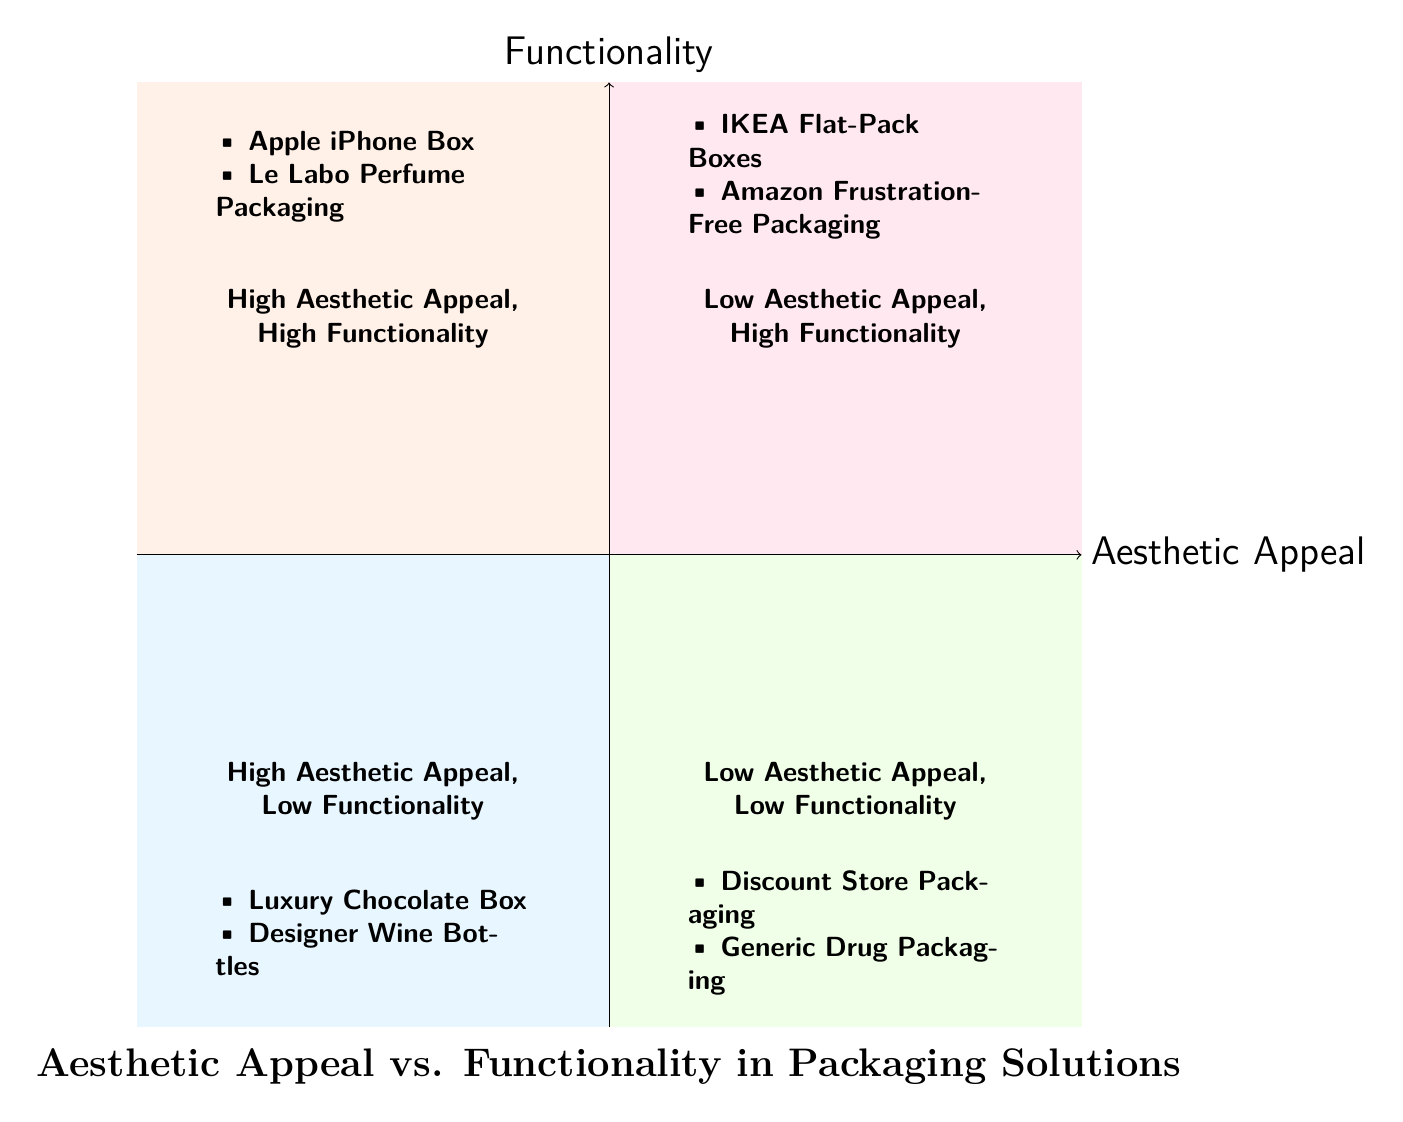What are the two examples in the high aesthetic appeal, high functionality quadrant? The quadrant contains two specific examples: the Apple iPhone Box and the Le Labo Perfume Packaging.
Answer: Apple iPhone Box, Le Labo Perfume Packaging Which quadrant contains the IKEA Flat-Pack Boxes? The IKEA Flat-Pack Boxes are located in the low aesthetic appeal, high functionality quadrant, which focuses on practicality over aesthetics.
Answer: Low Aesthetic Appeal, High Functionality How many examples are listed in the low aesthetic appeal, low functionality quadrant? The quadrant includes two examples: Discount Store Packaging and Generic Drug Packaging, indicating that both are unattractive and lack adequate protection.
Answer: 2 What type of products are in the high aesthetic appeal, low functionality quadrant? The products in this quadrant, such as the Luxury Chocolate Box and Designer Wine Bottles, are characterized by their beautiful designs but lack practical use or robustness.
Answer: Luxury Chocolate Box, Designer Wine Bottles Which quadrant has a focus on utility over aesthetics? The low aesthetic appeal, high functionality quadrant prioritizes utility, as seen with examples like IKEA Flat-Pack Boxes and Amazon Frustration-Free Packaging.
Answer: Low Aesthetic Appeal, High Functionality 